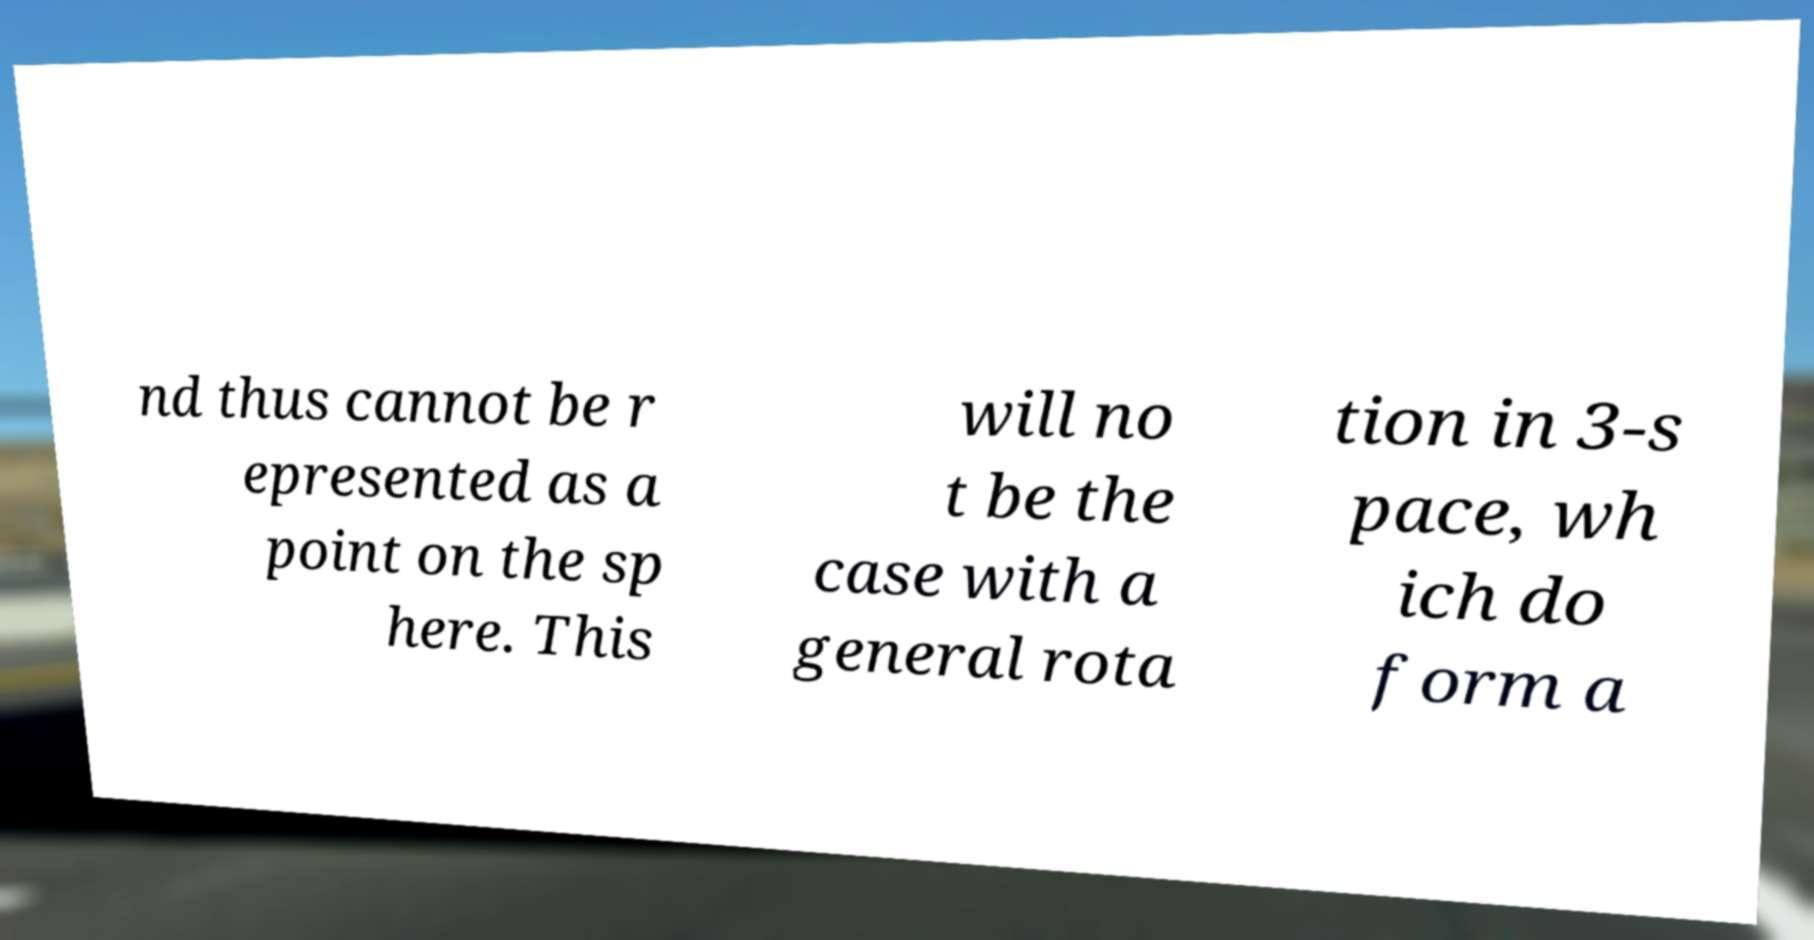I need the written content from this picture converted into text. Can you do that? nd thus cannot be r epresented as a point on the sp here. This will no t be the case with a general rota tion in 3-s pace, wh ich do form a 